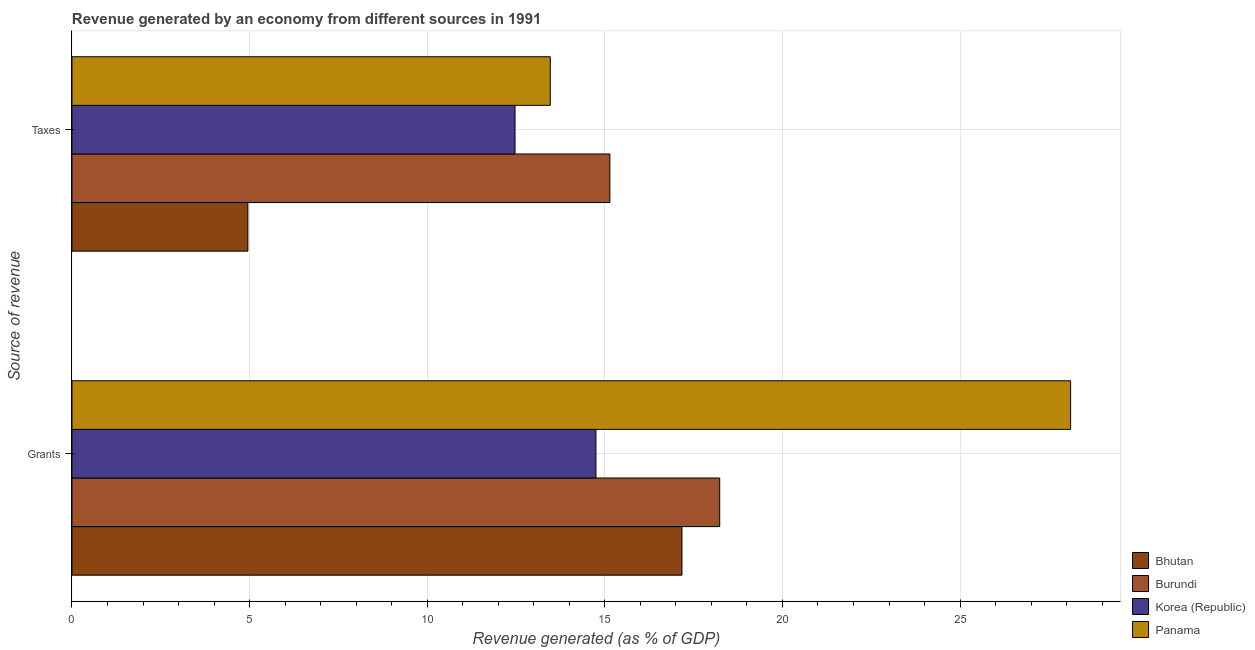How many different coloured bars are there?
Provide a succinct answer. 4. Are the number of bars on each tick of the Y-axis equal?
Make the answer very short. Yes. What is the label of the 2nd group of bars from the top?
Your answer should be very brief. Grants. What is the revenue generated by taxes in Bhutan?
Your response must be concise. 4.95. Across all countries, what is the maximum revenue generated by grants?
Provide a short and direct response. 28.11. Across all countries, what is the minimum revenue generated by grants?
Keep it short and to the point. 14.75. In which country was the revenue generated by grants maximum?
Your response must be concise. Panama. What is the total revenue generated by grants in the graph?
Provide a succinct answer. 78.27. What is the difference between the revenue generated by taxes in Panama and that in Burundi?
Offer a terse response. -1.68. What is the difference between the revenue generated by taxes in Korea (Republic) and the revenue generated by grants in Bhutan?
Give a very brief answer. -4.7. What is the average revenue generated by grants per country?
Your answer should be compact. 19.57. What is the difference between the revenue generated by taxes and revenue generated by grants in Panama?
Your answer should be very brief. -14.65. In how many countries, is the revenue generated by taxes greater than 20 %?
Your answer should be compact. 0. What is the ratio of the revenue generated by grants in Burundi to that in Panama?
Provide a short and direct response. 0.65. Is the revenue generated by grants in Bhutan less than that in Panama?
Your answer should be very brief. Yes. What does the 1st bar from the top in Taxes represents?
Your answer should be compact. Panama. What does the 2nd bar from the bottom in Grants represents?
Offer a terse response. Burundi. What is the difference between two consecutive major ticks on the X-axis?
Your response must be concise. 5. Are the values on the major ticks of X-axis written in scientific E-notation?
Make the answer very short. No. Does the graph contain grids?
Make the answer very short. Yes. Where does the legend appear in the graph?
Provide a succinct answer. Bottom right. How many legend labels are there?
Your answer should be very brief. 4. How are the legend labels stacked?
Give a very brief answer. Vertical. What is the title of the graph?
Offer a terse response. Revenue generated by an economy from different sources in 1991. What is the label or title of the X-axis?
Offer a terse response. Revenue generated (as % of GDP). What is the label or title of the Y-axis?
Ensure brevity in your answer.  Source of revenue. What is the Revenue generated (as % of GDP) of Bhutan in Grants?
Make the answer very short. 17.17. What is the Revenue generated (as % of GDP) of Burundi in Grants?
Keep it short and to the point. 18.23. What is the Revenue generated (as % of GDP) in Korea (Republic) in Grants?
Offer a terse response. 14.75. What is the Revenue generated (as % of GDP) in Panama in Grants?
Offer a very short reply. 28.11. What is the Revenue generated (as % of GDP) in Bhutan in Taxes?
Give a very brief answer. 4.95. What is the Revenue generated (as % of GDP) of Burundi in Taxes?
Your answer should be very brief. 15.14. What is the Revenue generated (as % of GDP) of Korea (Republic) in Taxes?
Make the answer very short. 12.47. What is the Revenue generated (as % of GDP) in Panama in Taxes?
Offer a terse response. 13.47. Across all Source of revenue, what is the maximum Revenue generated (as % of GDP) in Bhutan?
Your answer should be compact. 17.17. Across all Source of revenue, what is the maximum Revenue generated (as % of GDP) of Burundi?
Provide a short and direct response. 18.23. Across all Source of revenue, what is the maximum Revenue generated (as % of GDP) in Korea (Republic)?
Ensure brevity in your answer.  14.75. Across all Source of revenue, what is the maximum Revenue generated (as % of GDP) in Panama?
Provide a short and direct response. 28.11. Across all Source of revenue, what is the minimum Revenue generated (as % of GDP) of Bhutan?
Ensure brevity in your answer.  4.95. Across all Source of revenue, what is the minimum Revenue generated (as % of GDP) of Burundi?
Ensure brevity in your answer.  15.14. Across all Source of revenue, what is the minimum Revenue generated (as % of GDP) of Korea (Republic)?
Your answer should be very brief. 12.47. Across all Source of revenue, what is the minimum Revenue generated (as % of GDP) in Panama?
Your answer should be compact. 13.47. What is the total Revenue generated (as % of GDP) of Bhutan in the graph?
Offer a very short reply. 22.12. What is the total Revenue generated (as % of GDP) of Burundi in the graph?
Your answer should be very brief. 33.38. What is the total Revenue generated (as % of GDP) in Korea (Republic) in the graph?
Give a very brief answer. 27.22. What is the total Revenue generated (as % of GDP) in Panama in the graph?
Provide a short and direct response. 41.58. What is the difference between the Revenue generated (as % of GDP) in Bhutan in Grants and that in Taxes?
Keep it short and to the point. 12.22. What is the difference between the Revenue generated (as % of GDP) in Burundi in Grants and that in Taxes?
Make the answer very short. 3.09. What is the difference between the Revenue generated (as % of GDP) in Korea (Republic) in Grants and that in Taxes?
Give a very brief answer. 2.28. What is the difference between the Revenue generated (as % of GDP) in Panama in Grants and that in Taxes?
Your answer should be compact. 14.65. What is the difference between the Revenue generated (as % of GDP) of Bhutan in Grants and the Revenue generated (as % of GDP) of Burundi in Taxes?
Give a very brief answer. 2.03. What is the difference between the Revenue generated (as % of GDP) of Bhutan in Grants and the Revenue generated (as % of GDP) of Korea (Republic) in Taxes?
Your answer should be compact. 4.7. What is the difference between the Revenue generated (as % of GDP) in Bhutan in Grants and the Revenue generated (as % of GDP) in Panama in Taxes?
Ensure brevity in your answer.  3.71. What is the difference between the Revenue generated (as % of GDP) in Burundi in Grants and the Revenue generated (as % of GDP) in Korea (Republic) in Taxes?
Your response must be concise. 5.76. What is the difference between the Revenue generated (as % of GDP) in Burundi in Grants and the Revenue generated (as % of GDP) in Panama in Taxes?
Make the answer very short. 4.77. What is the difference between the Revenue generated (as % of GDP) in Korea (Republic) in Grants and the Revenue generated (as % of GDP) in Panama in Taxes?
Provide a short and direct response. 1.28. What is the average Revenue generated (as % of GDP) in Bhutan per Source of revenue?
Keep it short and to the point. 11.06. What is the average Revenue generated (as % of GDP) in Burundi per Source of revenue?
Provide a succinct answer. 16.69. What is the average Revenue generated (as % of GDP) in Korea (Republic) per Source of revenue?
Your response must be concise. 13.61. What is the average Revenue generated (as % of GDP) of Panama per Source of revenue?
Provide a succinct answer. 20.79. What is the difference between the Revenue generated (as % of GDP) in Bhutan and Revenue generated (as % of GDP) in Burundi in Grants?
Offer a terse response. -1.06. What is the difference between the Revenue generated (as % of GDP) in Bhutan and Revenue generated (as % of GDP) in Korea (Republic) in Grants?
Provide a succinct answer. 2.42. What is the difference between the Revenue generated (as % of GDP) of Bhutan and Revenue generated (as % of GDP) of Panama in Grants?
Keep it short and to the point. -10.94. What is the difference between the Revenue generated (as % of GDP) in Burundi and Revenue generated (as % of GDP) in Korea (Republic) in Grants?
Keep it short and to the point. 3.48. What is the difference between the Revenue generated (as % of GDP) in Burundi and Revenue generated (as % of GDP) in Panama in Grants?
Make the answer very short. -9.88. What is the difference between the Revenue generated (as % of GDP) of Korea (Republic) and Revenue generated (as % of GDP) of Panama in Grants?
Your response must be concise. -13.36. What is the difference between the Revenue generated (as % of GDP) of Bhutan and Revenue generated (as % of GDP) of Burundi in Taxes?
Provide a short and direct response. -10.19. What is the difference between the Revenue generated (as % of GDP) in Bhutan and Revenue generated (as % of GDP) in Korea (Republic) in Taxes?
Keep it short and to the point. -7.52. What is the difference between the Revenue generated (as % of GDP) in Bhutan and Revenue generated (as % of GDP) in Panama in Taxes?
Your answer should be very brief. -8.51. What is the difference between the Revenue generated (as % of GDP) in Burundi and Revenue generated (as % of GDP) in Korea (Republic) in Taxes?
Ensure brevity in your answer.  2.67. What is the difference between the Revenue generated (as % of GDP) of Burundi and Revenue generated (as % of GDP) of Panama in Taxes?
Ensure brevity in your answer.  1.68. What is the difference between the Revenue generated (as % of GDP) of Korea (Republic) and Revenue generated (as % of GDP) of Panama in Taxes?
Make the answer very short. -0.99. What is the ratio of the Revenue generated (as % of GDP) of Bhutan in Grants to that in Taxes?
Offer a very short reply. 3.47. What is the ratio of the Revenue generated (as % of GDP) in Burundi in Grants to that in Taxes?
Offer a very short reply. 1.2. What is the ratio of the Revenue generated (as % of GDP) of Korea (Republic) in Grants to that in Taxes?
Keep it short and to the point. 1.18. What is the ratio of the Revenue generated (as % of GDP) of Panama in Grants to that in Taxes?
Provide a succinct answer. 2.09. What is the difference between the highest and the second highest Revenue generated (as % of GDP) in Bhutan?
Your answer should be compact. 12.22. What is the difference between the highest and the second highest Revenue generated (as % of GDP) in Burundi?
Your answer should be compact. 3.09. What is the difference between the highest and the second highest Revenue generated (as % of GDP) of Korea (Republic)?
Offer a terse response. 2.28. What is the difference between the highest and the second highest Revenue generated (as % of GDP) in Panama?
Keep it short and to the point. 14.65. What is the difference between the highest and the lowest Revenue generated (as % of GDP) of Bhutan?
Provide a short and direct response. 12.22. What is the difference between the highest and the lowest Revenue generated (as % of GDP) in Burundi?
Keep it short and to the point. 3.09. What is the difference between the highest and the lowest Revenue generated (as % of GDP) in Korea (Republic)?
Your answer should be very brief. 2.28. What is the difference between the highest and the lowest Revenue generated (as % of GDP) in Panama?
Offer a very short reply. 14.65. 